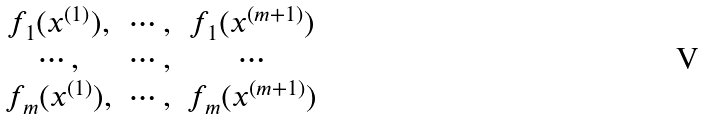Convert formula to latex. <formula><loc_0><loc_0><loc_500><loc_500>\begin{matrix} f _ { 1 } ( x ^ { ( 1 ) } ) , & \cdots , & f _ { 1 } ( x ^ { ( m + 1 ) } ) \\ \cdots , & \cdots , & \cdots \\ f _ { m } ( x ^ { ( 1 ) } ) , & \cdots , & f _ { m } ( x ^ { ( m + 1 ) } ) \end{matrix}</formula> 